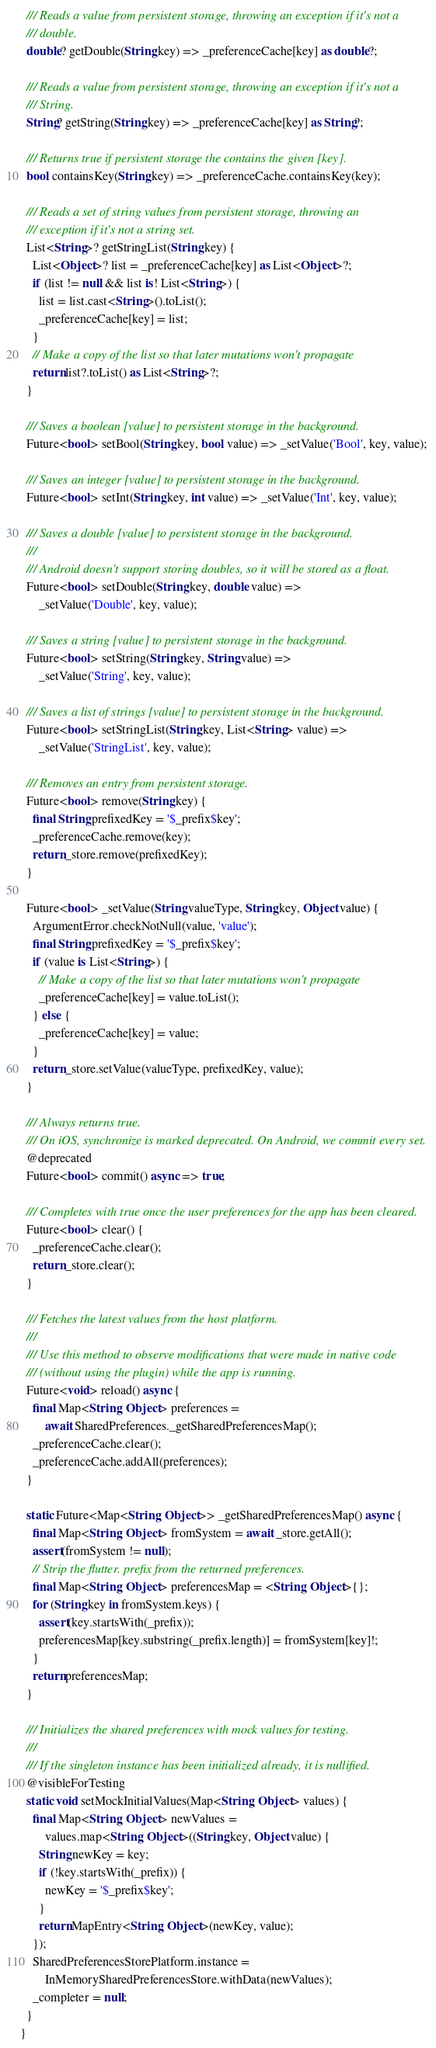Convert code to text. <code><loc_0><loc_0><loc_500><loc_500><_Dart_>
  /// Reads a value from persistent storage, throwing an exception if it's not a
  /// double.
  double? getDouble(String key) => _preferenceCache[key] as double?;

  /// Reads a value from persistent storage, throwing an exception if it's not a
  /// String.
  String? getString(String key) => _preferenceCache[key] as String?;

  /// Returns true if persistent storage the contains the given [key].
  bool containsKey(String key) => _preferenceCache.containsKey(key);

  /// Reads a set of string values from persistent storage, throwing an
  /// exception if it's not a string set.
  List<String>? getStringList(String key) {
    List<Object>? list = _preferenceCache[key] as List<Object>?;
    if (list != null && list is! List<String>) {
      list = list.cast<String>().toList();
      _preferenceCache[key] = list;
    }
    // Make a copy of the list so that later mutations won't propagate
    return list?.toList() as List<String>?;
  }

  /// Saves a boolean [value] to persistent storage in the background.
  Future<bool> setBool(String key, bool value) => _setValue('Bool', key, value);

  /// Saves an integer [value] to persistent storage in the background.
  Future<bool> setInt(String key, int value) => _setValue('Int', key, value);

  /// Saves a double [value] to persistent storage in the background.
  ///
  /// Android doesn't support storing doubles, so it will be stored as a float.
  Future<bool> setDouble(String key, double value) =>
      _setValue('Double', key, value);

  /// Saves a string [value] to persistent storage in the background.
  Future<bool> setString(String key, String value) =>
      _setValue('String', key, value);

  /// Saves a list of strings [value] to persistent storage in the background.
  Future<bool> setStringList(String key, List<String> value) =>
      _setValue('StringList', key, value);

  /// Removes an entry from persistent storage.
  Future<bool> remove(String key) {
    final String prefixedKey = '$_prefix$key';
    _preferenceCache.remove(key);
    return _store.remove(prefixedKey);
  }

  Future<bool> _setValue(String valueType, String key, Object value) {
    ArgumentError.checkNotNull(value, 'value');
    final String prefixedKey = '$_prefix$key';
    if (value is List<String>) {
      // Make a copy of the list so that later mutations won't propagate
      _preferenceCache[key] = value.toList();
    } else {
      _preferenceCache[key] = value;
    }
    return _store.setValue(valueType, prefixedKey, value);
  }

  /// Always returns true.
  /// On iOS, synchronize is marked deprecated. On Android, we commit every set.
  @deprecated
  Future<bool> commit() async => true;

  /// Completes with true once the user preferences for the app has been cleared.
  Future<bool> clear() {
    _preferenceCache.clear();
    return _store.clear();
  }

  /// Fetches the latest values from the host platform.
  ///
  /// Use this method to observe modifications that were made in native code
  /// (without using the plugin) while the app is running.
  Future<void> reload() async {
    final Map<String, Object> preferences =
        await SharedPreferences._getSharedPreferencesMap();
    _preferenceCache.clear();
    _preferenceCache.addAll(preferences);
  }

  static Future<Map<String, Object>> _getSharedPreferencesMap() async {
    final Map<String, Object> fromSystem = await _store.getAll();
    assert(fromSystem != null);
    // Strip the flutter. prefix from the returned preferences.
    final Map<String, Object> preferencesMap = <String, Object>{};
    for (String key in fromSystem.keys) {
      assert(key.startsWith(_prefix));
      preferencesMap[key.substring(_prefix.length)] = fromSystem[key]!;
    }
    return preferencesMap;
  }

  /// Initializes the shared preferences with mock values for testing.
  ///
  /// If the singleton instance has been initialized already, it is nullified.
  @visibleForTesting
  static void setMockInitialValues(Map<String, Object> values) {
    final Map<String, Object> newValues =
        values.map<String, Object>((String key, Object value) {
      String newKey = key;
      if (!key.startsWith(_prefix)) {
        newKey = '$_prefix$key';
      }
      return MapEntry<String, Object>(newKey, value);
    });
    SharedPreferencesStorePlatform.instance =
        InMemorySharedPreferencesStore.withData(newValues);
    _completer = null;
  }
}
</code> 